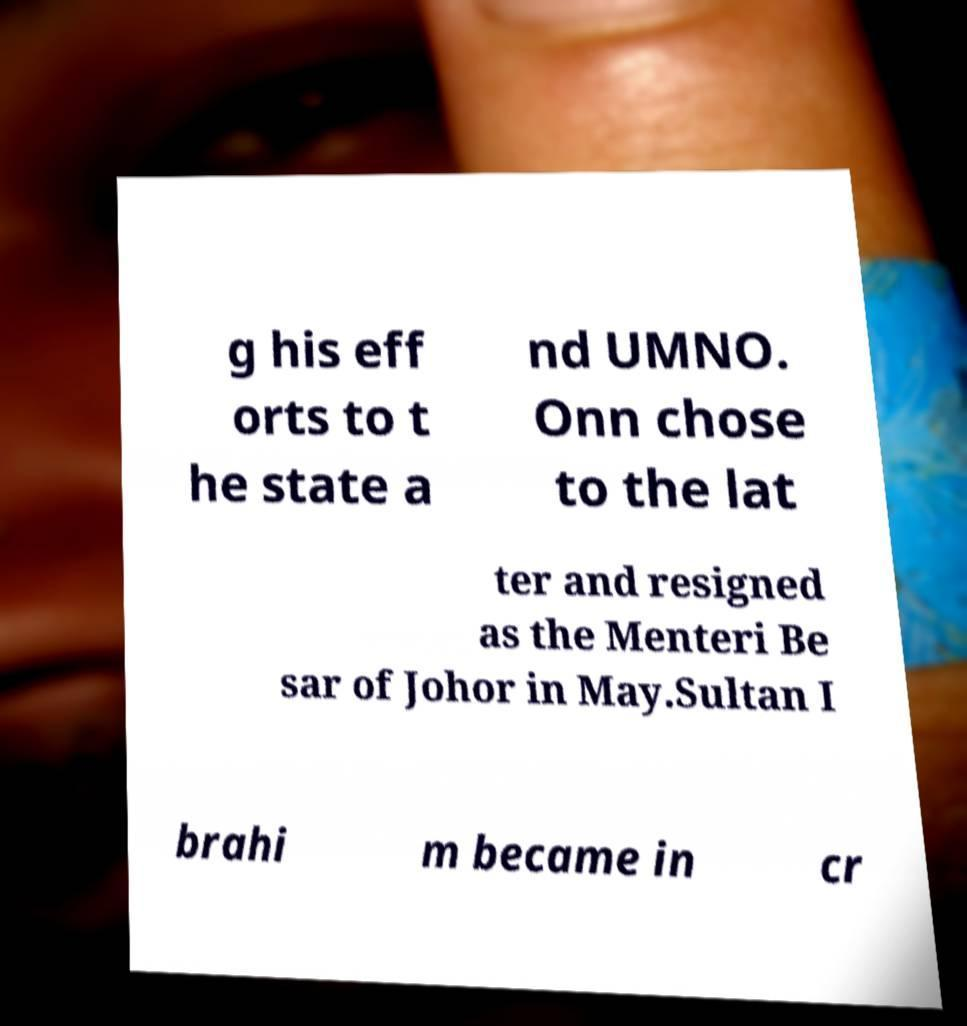What messages or text are displayed in this image? I need them in a readable, typed format. g his eff orts to t he state a nd UMNO. Onn chose to the lat ter and resigned as the Menteri Be sar of Johor in May.Sultan I brahi m became in cr 